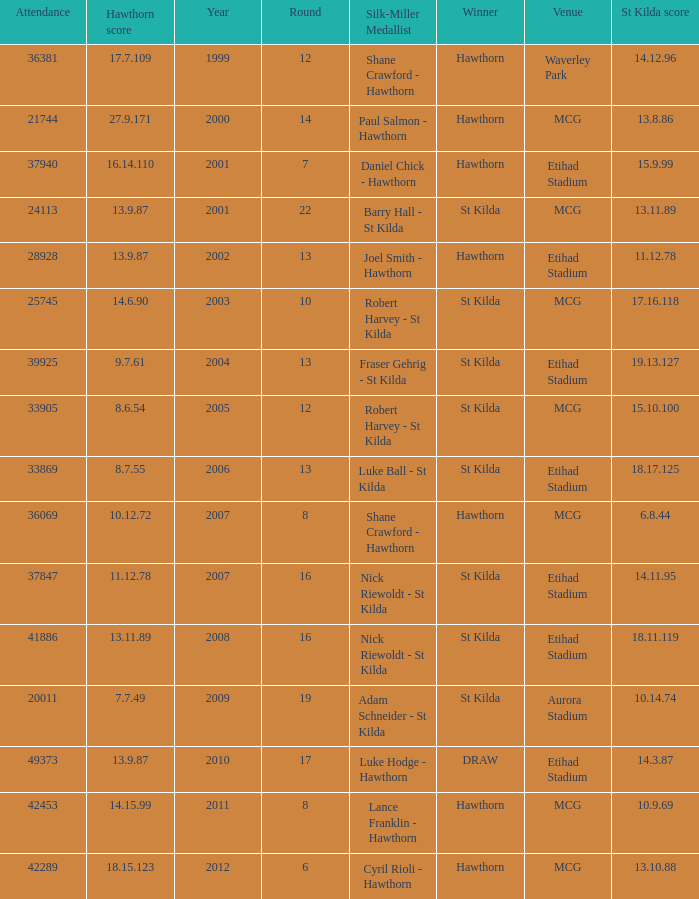What the listed in round when the hawthorn score is 17.7.109? 12.0. 